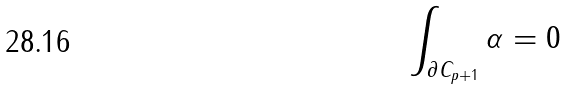<formula> <loc_0><loc_0><loc_500><loc_500>\int _ { \partial C _ { p + 1 } } \alpha = 0 \,</formula> 